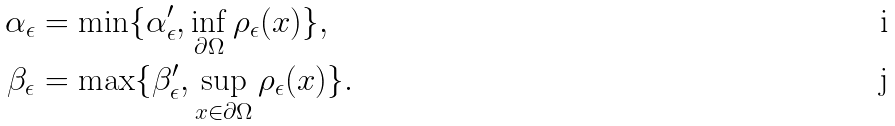<formula> <loc_0><loc_0><loc_500><loc_500>\alpha _ { \epsilon } & = \min \{ \alpha ^ { \prime } _ { \epsilon } , \inf _ { \partial \Omega } \rho _ { \epsilon } ( x ) \} , \\ \beta _ { \epsilon } & = \max \{ \beta ^ { \prime } _ { \epsilon } , \sup _ { x \in \partial \Omega } \rho _ { \epsilon } ( x ) \} .</formula> 